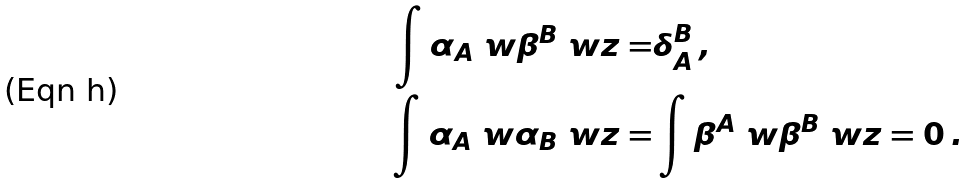<formula> <loc_0><loc_0><loc_500><loc_500>\int { \alpha _ { A } \ w \beta ^ { B } \ w z } = & \delta ^ { B } _ { A } \, , \\ \int { \alpha _ { A } \ w \alpha _ { B } \ w z } = & \int { \beta ^ { A } \ w \beta ^ { B } \ w z } = 0 \, .</formula> 